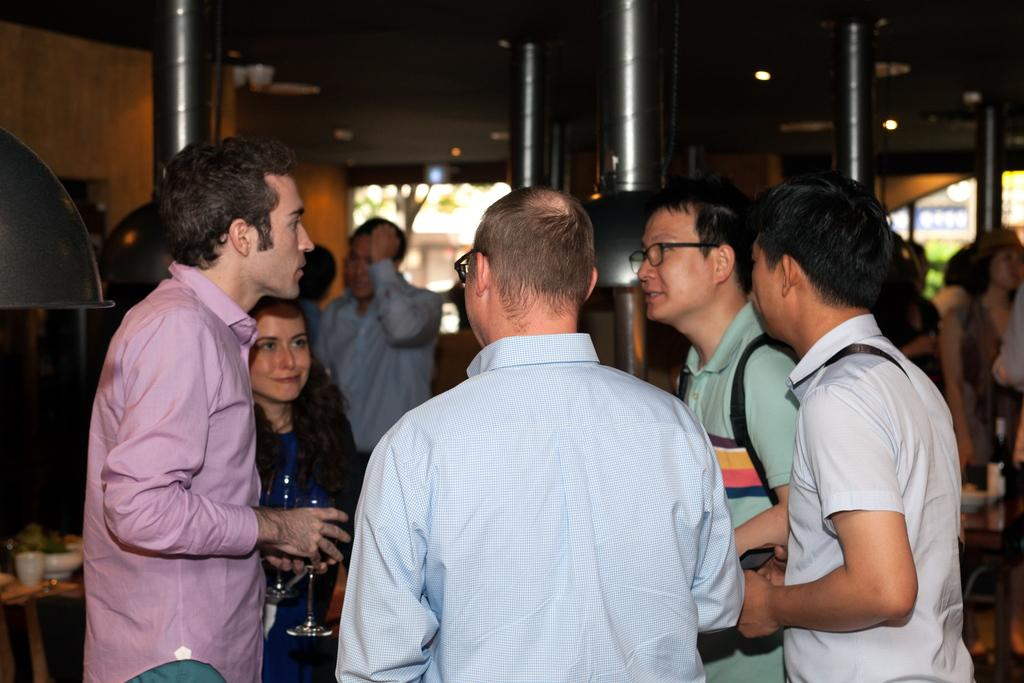What is happening with the persons in the image? The persons are standing and discussing in the image. What can be seen in the background of the image? There are steel pillars and a wall in the background of the image. What type of fuel is being used by the persons in the image? There is no mention of fuel or any related activity in the image. 